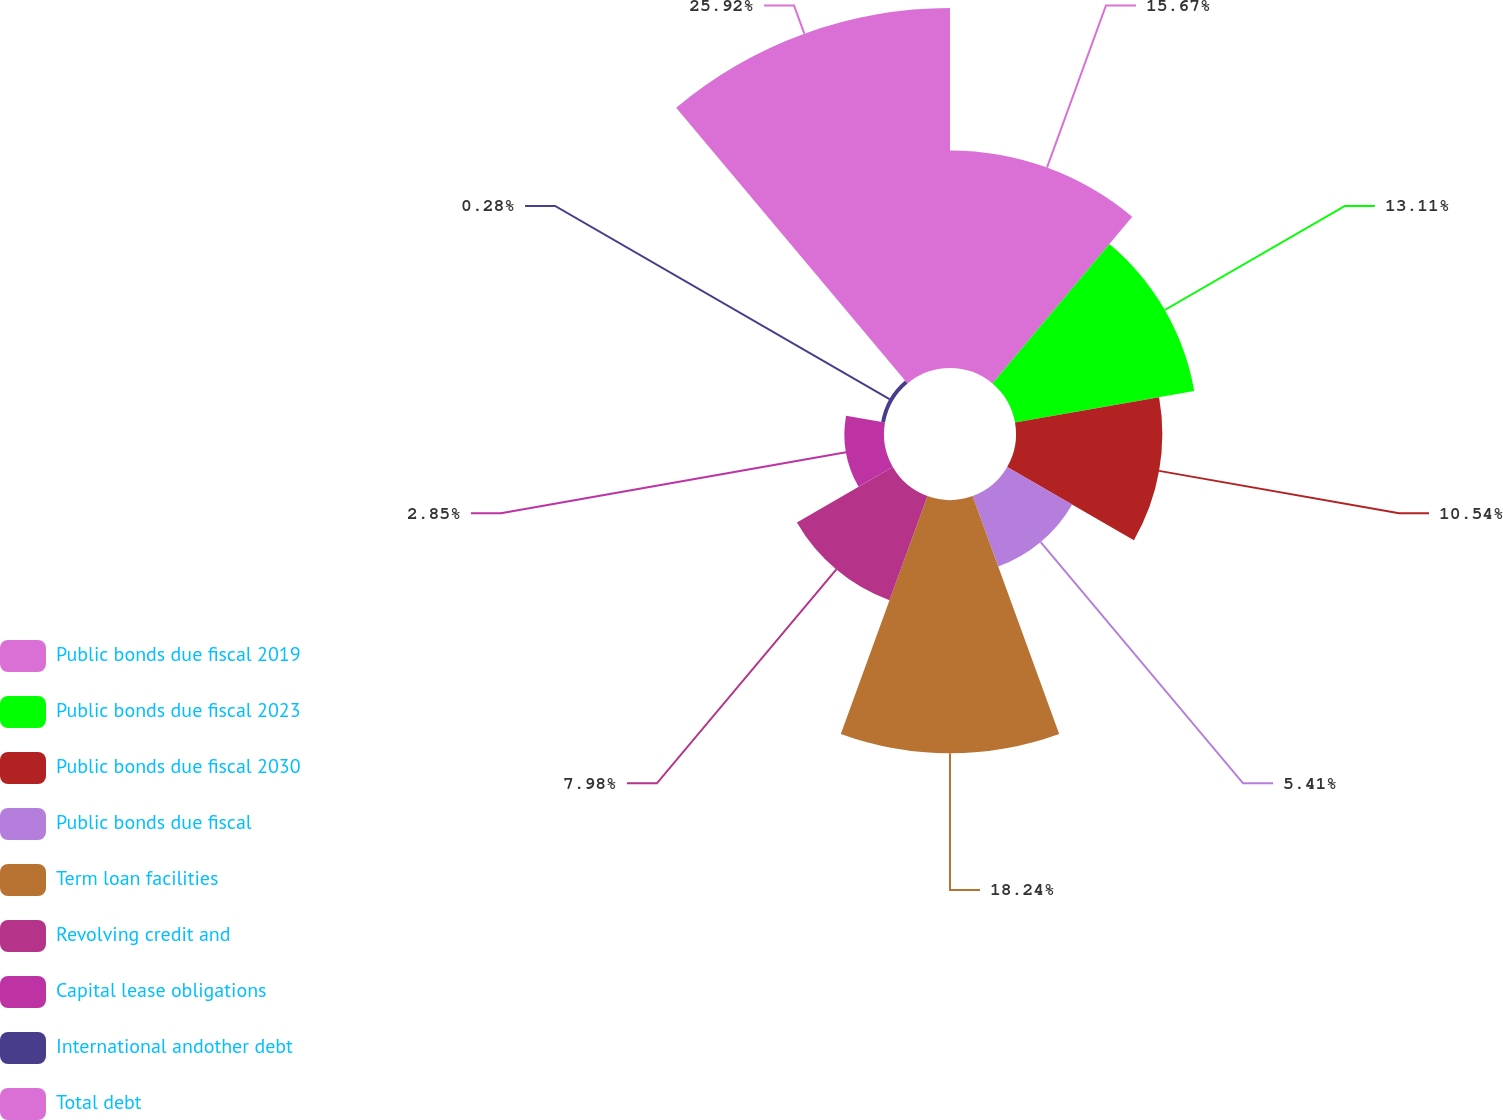Convert chart to OTSL. <chart><loc_0><loc_0><loc_500><loc_500><pie_chart><fcel>Public bonds due fiscal 2019<fcel>Public bonds due fiscal 2023<fcel>Public bonds due fiscal 2030<fcel>Public bonds due fiscal<fcel>Term loan facilities<fcel>Revolving credit and<fcel>Capital lease obligations<fcel>International andother debt<fcel>Total debt<nl><fcel>15.67%<fcel>13.11%<fcel>10.54%<fcel>5.41%<fcel>18.24%<fcel>7.98%<fcel>2.85%<fcel>0.28%<fcel>25.93%<nl></chart> 